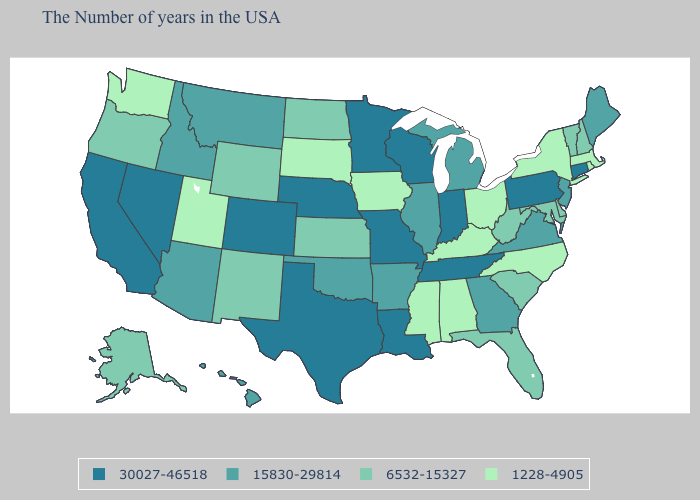Is the legend a continuous bar?
Concise answer only. No. Name the states that have a value in the range 30027-46518?
Short answer required. Connecticut, Pennsylvania, Indiana, Tennessee, Wisconsin, Louisiana, Missouri, Minnesota, Nebraska, Texas, Colorado, Nevada, California. What is the value of Alabama?
Give a very brief answer. 1228-4905. What is the value of Utah?
Keep it brief. 1228-4905. What is the value of Wisconsin?
Quick response, please. 30027-46518. Does Kentucky have the same value as Utah?
Quick response, please. Yes. Does Florida have the highest value in the USA?
Short answer required. No. What is the highest value in the USA?
Short answer required. 30027-46518. What is the highest value in the USA?
Short answer required. 30027-46518. Name the states that have a value in the range 6532-15327?
Write a very short answer. New Hampshire, Vermont, Delaware, Maryland, South Carolina, West Virginia, Florida, Kansas, North Dakota, Wyoming, New Mexico, Oregon, Alaska. Name the states that have a value in the range 1228-4905?
Answer briefly. Massachusetts, Rhode Island, New York, North Carolina, Ohio, Kentucky, Alabama, Mississippi, Iowa, South Dakota, Utah, Washington. Name the states that have a value in the range 1228-4905?
Write a very short answer. Massachusetts, Rhode Island, New York, North Carolina, Ohio, Kentucky, Alabama, Mississippi, Iowa, South Dakota, Utah, Washington. Which states have the lowest value in the USA?
Short answer required. Massachusetts, Rhode Island, New York, North Carolina, Ohio, Kentucky, Alabama, Mississippi, Iowa, South Dakota, Utah, Washington. Among the states that border Tennessee , does North Carolina have the lowest value?
Short answer required. Yes. Name the states that have a value in the range 6532-15327?
Write a very short answer. New Hampshire, Vermont, Delaware, Maryland, South Carolina, West Virginia, Florida, Kansas, North Dakota, Wyoming, New Mexico, Oregon, Alaska. 